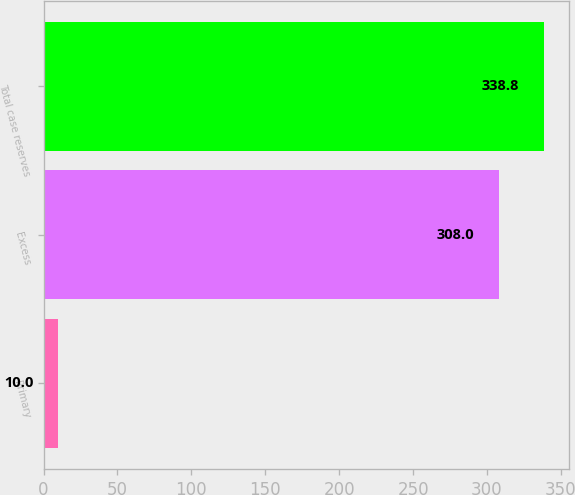Convert chart to OTSL. <chart><loc_0><loc_0><loc_500><loc_500><bar_chart><fcel>Primary<fcel>Excess<fcel>Total case reserves<nl><fcel>10<fcel>308<fcel>338.8<nl></chart> 